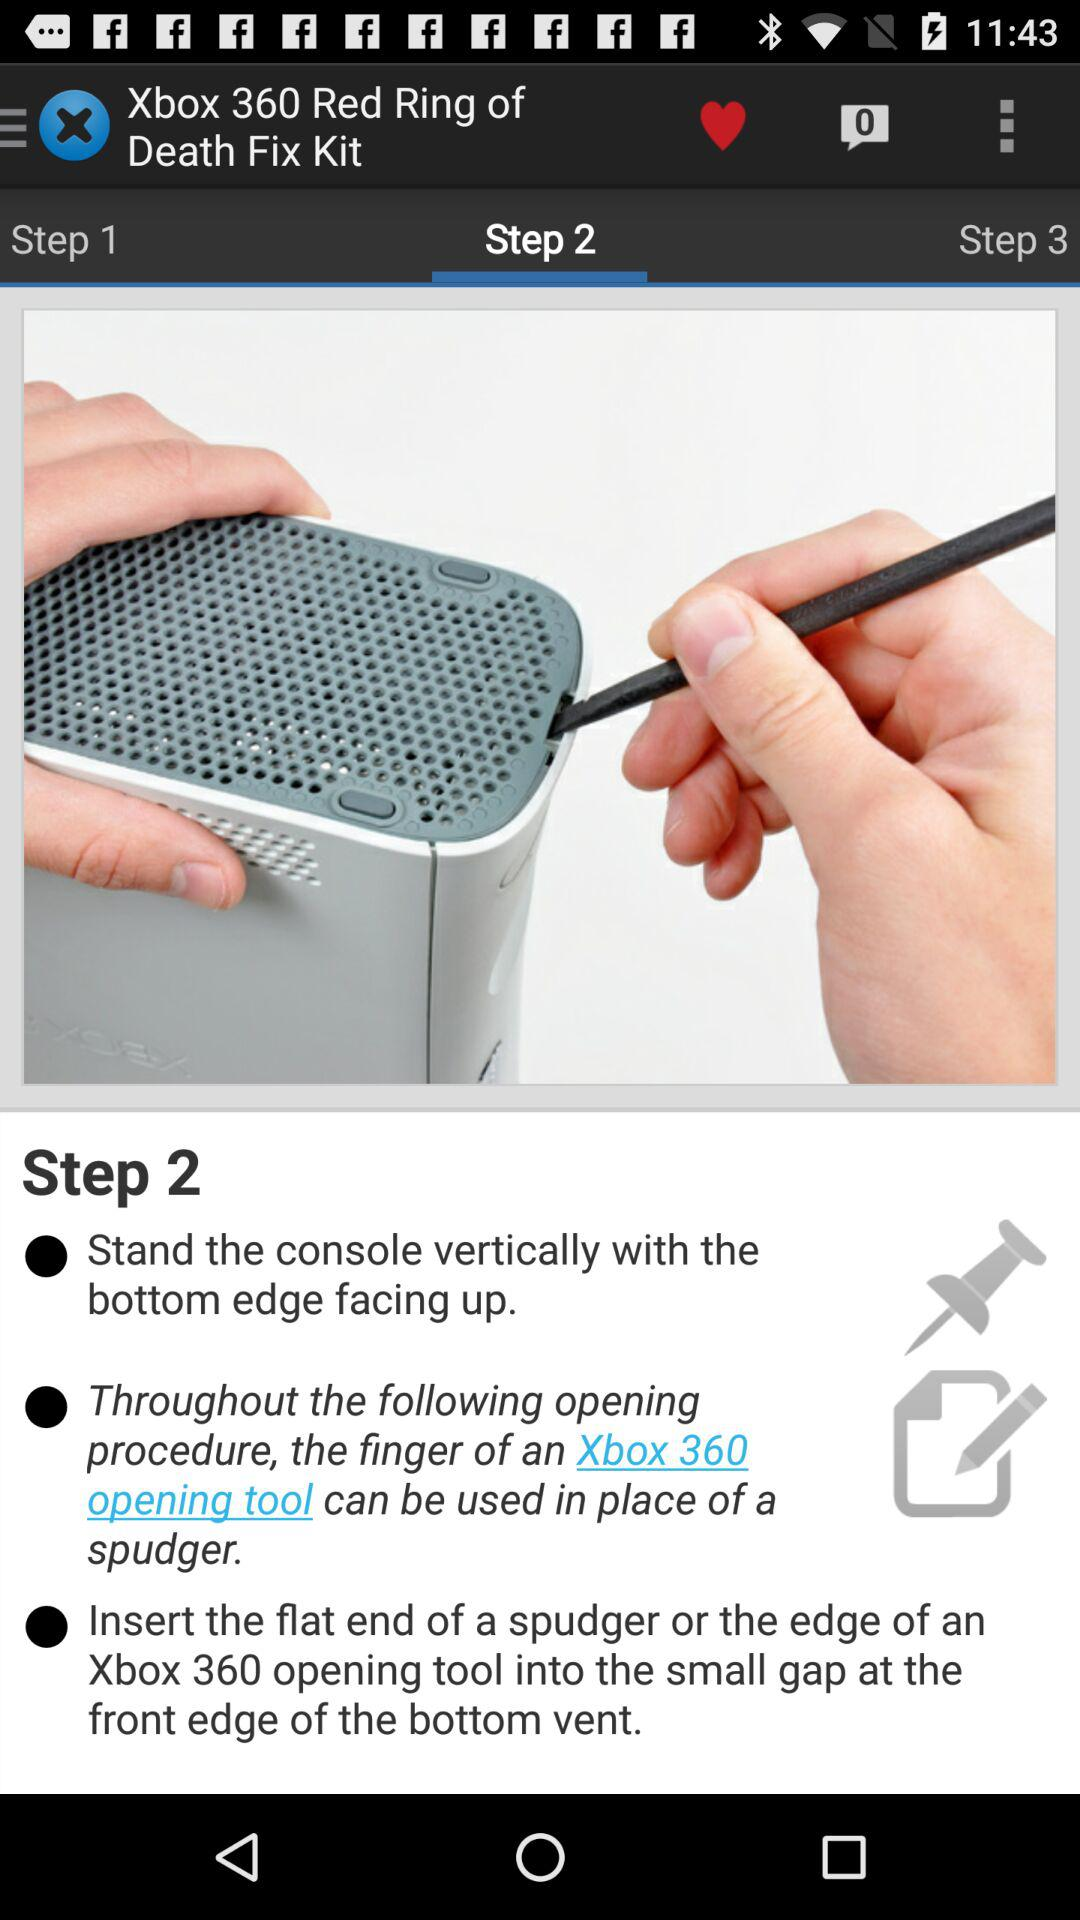Which step is shown on the screen? The shown step is 2. 